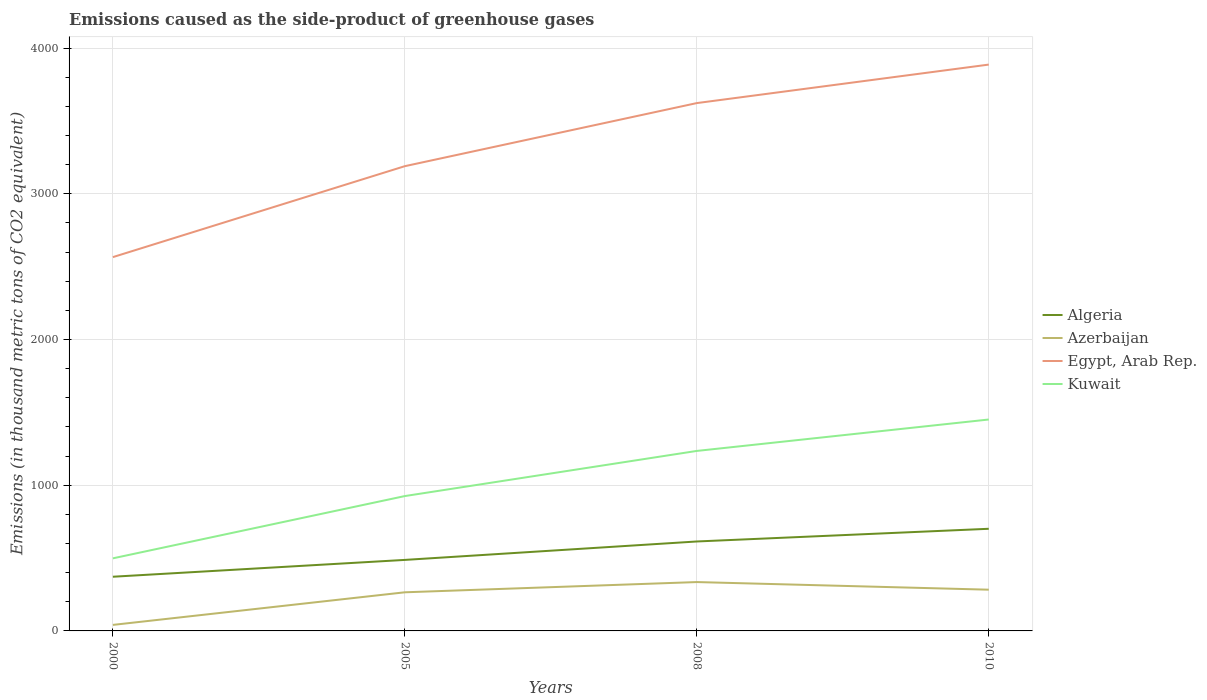How many different coloured lines are there?
Your response must be concise. 4. Across all years, what is the maximum emissions caused as the side-product of greenhouse gases in Egypt, Arab Rep.?
Your answer should be very brief. 2565.6. In which year was the emissions caused as the side-product of greenhouse gases in Azerbaijan maximum?
Your answer should be very brief. 2000. What is the total emissions caused as the side-product of greenhouse gases in Algeria in the graph?
Keep it short and to the point. -242. What is the difference between the highest and the second highest emissions caused as the side-product of greenhouse gases in Azerbaijan?
Offer a very short reply. 294. What is the difference between the highest and the lowest emissions caused as the side-product of greenhouse gases in Algeria?
Make the answer very short. 2. Is the emissions caused as the side-product of greenhouse gases in Algeria strictly greater than the emissions caused as the side-product of greenhouse gases in Azerbaijan over the years?
Make the answer very short. No. How many lines are there?
Make the answer very short. 4. Does the graph contain grids?
Offer a very short reply. Yes. Where does the legend appear in the graph?
Provide a short and direct response. Center right. How are the legend labels stacked?
Offer a terse response. Vertical. What is the title of the graph?
Provide a succinct answer. Emissions caused as the side-product of greenhouse gases. Does "Sierra Leone" appear as one of the legend labels in the graph?
Give a very brief answer. No. What is the label or title of the Y-axis?
Make the answer very short. Emissions (in thousand metric tons of CO2 equivalent). What is the Emissions (in thousand metric tons of CO2 equivalent) of Algeria in 2000?
Make the answer very short. 371.9. What is the Emissions (in thousand metric tons of CO2 equivalent) in Azerbaijan in 2000?
Your answer should be very brief. 41.3. What is the Emissions (in thousand metric tons of CO2 equivalent) of Egypt, Arab Rep. in 2000?
Offer a terse response. 2565.6. What is the Emissions (in thousand metric tons of CO2 equivalent) of Kuwait in 2000?
Provide a short and direct response. 498.2. What is the Emissions (in thousand metric tons of CO2 equivalent) of Algeria in 2005?
Offer a very short reply. 487.4. What is the Emissions (in thousand metric tons of CO2 equivalent) of Azerbaijan in 2005?
Your response must be concise. 265.1. What is the Emissions (in thousand metric tons of CO2 equivalent) in Egypt, Arab Rep. in 2005?
Make the answer very short. 3189.8. What is the Emissions (in thousand metric tons of CO2 equivalent) in Kuwait in 2005?
Make the answer very short. 925.6. What is the Emissions (in thousand metric tons of CO2 equivalent) in Algeria in 2008?
Your response must be concise. 613.9. What is the Emissions (in thousand metric tons of CO2 equivalent) in Azerbaijan in 2008?
Keep it short and to the point. 335.3. What is the Emissions (in thousand metric tons of CO2 equivalent) of Egypt, Arab Rep. in 2008?
Your response must be concise. 3622.8. What is the Emissions (in thousand metric tons of CO2 equivalent) in Kuwait in 2008?
Offer a terse response. 1235.4. What is the Emissions (in thousand metric tons of CO2 equivalent) of Algeria in 2010?
Keep it short and to the point. 701. What is the Emissions (in thousand metric tons of CO2 equivalent) of Azerbaijan in 2010?
Your answer should be very brief. 283. What is the Emissions (in thousand metric tons of CO2 equivalent) in Egypt, Arab Rep. in 2010?
Your response must be concise. 3887. What is the Emissions (in thousand metric tons of CO2 equivalent) of Kuwait in 2010?
Ensure brevity in your answer.  1451. Across all years, what is the maximum Emissions (in thousand metric tons of CO2 equivalent) in Algeria?
Your answer should be compact. 701. Across all years, what is the maximum Emissions (in thousand metric tons of CO2 equivalent) in Azerbaijan?
Ensure brevity in your answer.  335.3. Across all years, what is the maximum Emissions (in thousand metric tons of CO2 equivalent) of Egypt, Arab Rep.?
Offer a terse response. 3887. Across all years, what is the maximum Emissions (in thousand metric tons of CO2 equivalent) in Kuwait?
Offer a very short reply. 1451. Across all years, what is the minimum Emissions (in thousand metric tons of CO2 equivalent) of Algeria?
Keep it short and to the point. 371.9. Across all years, what is the minimum Emissions (in thousand metric tons of CO2 equivalent) of Azerbaijan?
Provide a succinct answer. 41.3. Across all years, what is the minimum Emissions (in thousand metric tons of CO2 equivalent) in Egypt, Arab Rep.?
Keep it short and to the point. 2565.6. Across all years, what is the minimum Emissions (in thousand metric tons of CO2 equivalent) of Kuwait?
Your response must be concise. 498.2. What is the total Emissions (in thousand metric tons of CO2 equivalent) in Algeria in the graph?
Offer a very short reply. 2174.2. What is the total Emissions (in thousand metric tons of CO2 equivalent) of Azerbaijan in the graph?
Offer a very short reply. 924.7. What is the total Emissions (in thousand metric tons of CO2 equivalent) of Egypt, Arab Rep. in the graph?
Provide a short and direct response. 1.33e+04. What is the total Emissions (in thousand metric tons of CO2 equivalent) of Kuwait in the graph?
Your response must be concise. 4110.2. What is the difference between the Emissions (in thousand metric tons of CO2 equivalent) of Algeria in 2000 and that in 2005?
Provide a short and direct response. -115.5. What is the difference between the Emissions (in thousand metric tons of CO2 equivalent) in Azerbaijan in 2000 and that in 2005?
Ensure brevity in your answer.  -223.8. What is the difference between the Emissions (in thousand metric tons of CO2 equivalent) of Egypt, Arab Rep. in 2000 and that in 2005?
Give a very brief answer. -624.2. What is the difference between the Emissions (in thousand metric tons of CO2 equivalent) of Kuwait in 2000 and that in 2005?
Make the answer very short. -427.4. What is the difference between the Emissions (in thousand metric tons of CO2 equivalent) in Algeria in 2000 and that in 2008?
Your answer should be very brief. -242. What is the difference between the Emissions (in thousand metric tons of CO2 equivalent) in Azerbaijan in 2000 and that in 2008?
Your answer should be compact. -294. What is the difference between the Emissions (in thousand metric tons of CO2 equivalent) of Egypt, Arab Rep. in 2000 and that in 2008?
Your answer should be compact. -1057.2. What is the difference between the Emissions (in thousand metric tons of CO2 equivalent) in Kuwait in 2000 and that in 2008?
Your answer should be compact. -737.2. What is the difference between the Emissions (in thousand metric tons of CO2 equivalent) of Algeria in 2000 and that in 2010?
Provide a short and direct response. -329.1. What is the difference between the Emissions (in thousand metric tons of CO2 equivalent) in Azerbaijan in 2000 and that in 2010?
Provide a succinct answer. -241.7. What is the difference between the Emissions (in thousand metric tons of CO2 equivalent) in Egypt, Arab Rep. in 2000 and that in 2010?
Ensure brevity in your answer.  -1321.4. What is the difference between the Emissions (in thousand metric tons of CO2 equivalent) in Kuwait in 2000 and that in 2010?
Your answer should be very brief. -952.8. What is the difference between the Emissions (in thousand metric tons of CO2 equivalent) in Algeria in 2005 and that in 2008?
Your answer should be very brief. -126.5. What is the difference between the Emissions (in thousand metric tons of CO2 equivalent) of Azerbaijan in 2005 and that in 2008?
Your answer should be compact. -70.2. What is the difference between the Emissions (in thousand metric tons of CO2 equivalent) in Egypt, Arab Rep. in 2005 and that in 2008?
Provide a short and direct response. -433. What is the difference between the Emissions (in thousand metric tons of CO2 equivalent) in Kuwait in 2005 and that in 2008?
Offer a very short reply. -309.8. What is the difference between the Emissions (in thousand metric tons of CO2 equivalent) of Algeria in 2005 and that in 2010?
Your answer should be compact. -213.6. What is the difference between the Emissions (in thousand metric tons of CO2 equivalent) in Azerbaijan in 2005 and that in 2010?
Provide a short and direct response. -17.9. What is the difference between the Emissions (in thousand metric tons of CO2 equivalent) in Egypt, Arab Rep. in 2005 and that in 2010?
Ensure brevity in your answer.  -697.2. What is the difference between the Emissions (in thousand metric tons of CO2 equivalent) in Kuwait in 2005 and that in 2010?
Keep it short and to the point. -525.4. What is the difference between the Emissions (in thousand metric tons of CO2 equivalent) in Algeria in 2008 and that in 2010?
Your answer should be very brief. -87.1. What is the difference between the Emissions (in thousand metric tons of CO2 equivalent) in Azerbaijan in 2008 and that in 2010?
Ensure brevity in your answer.  52.3. What is the difference between the Emissions (in thousand metric tons of CO2 equivalent) of Egypt, Arab Rep. in 2008 and that in 2010?
Your answer should be compact. -264.2. What is the difference between the Emissions (in thousand metric tons of CO2 equivalent) of Kuwait in 2008 and that in 2010?
Give a very brief answer. -215.6. What is the difference between the Emissions (in thousand metric tons of CO2 equivalent) in Algeria in 2000 and the Emissions (in thousand metric tons of CO2 equivalent) in Azerbaijan in 2005?
Your answer should be compact. 106.8. What is the difference between the Emissions (in thousand metric tons of CO2 equivalent) in Algeria in 2000 and the Emissions (in thousand metric tons of CO2 equivalent) in Egypt, Arab Rep. in 2005?
Offer a very short reply. -2817.9. What is the difference between the Emissions (in thousand metric tons of CO2 equivalent) of Algeria in 2000 and the Emissions (in thousand metric tons of CO2 equivalent) of Kuwait in 2005?
Your answer should be compact. -553.7. What is the difference between the Emissions (in thousand metric tons of CO2 equivalent) in Azerbaijan in 2000 and the Emissions (in thousand metric tons of CO2 equivalent) in Egypt, Arab Rep. in 2005?
Provide a short and direct response. -3148.5. What is the difference between the Emissions (in thousand metric tons of CO2 equivalent) in Azerbaijan in 2000 and the Emissions (in thousand metric tons of CO2 equivalent) in Kuwait in 2005?
Your answer should be compact. -884.3. What is the difference between the Emissions (in thousand metric tons of CO2 equivalent) of Egypt, Arab Rep. in 2000 and the Emissions (in thousand metric tons of CO2 equivalent) of Kuwait in 2005?
Your response must be concise. 1640. What is the difference between the Emissions (in thousand metric tons of CO2 equivalent) of Algeria in 2000 and the Emissions (in thousand metric tons of CO2 equivalent) of Azerbaijan in 2008?
Your answer should be very brief. 36.6. What is the difference between the Emissions (in thousand metric tons of CO2 equivalent) of Algeria in 2000 and the Emissions (in thousand metric tons of CO2 equivalent) of Egypt, Arab Rep. in 2008?
Your answer should be compact. -3250.9. What is the difference between the Emissions (in thousand metric tons of CO2 equivalent) in Algeria in 2000 and the Emissions (in thousand metric tons of CO2 equivalent) in Kuwait in 2008?
Ensure brevity in your answer.  -863.5. What is the difference between the Emissions (in thousand metric tons of CO2 equivalent) in Azerbaijan in 2000 and the Emissions (in thousand metric tons of CO2 equivalent) in Egypt, Arab Rep. in 2008?
Your response must be concise. -3581.5. What is the difference between the Emissions (in thousand metric tons of CO2 equivalent) in Azerbaijan in 2000 and the Emissions (in thousand metric tons of CO2 equivalent) in Kuwait in 2008?
Keep it short and to the point. -1194.1. What is the difference between the Emissions (in thousand metric tons of CO2 equivalent) in Egypt, Arab Rep. in 2000 and the Emissions (in thousand metric tons of CO2 equivalent) in Kuwait in 2008?
Make the answer very short. 1330.2. What is the difference between the Emissions (in thousand metric tons of CO2 equivalent) in Algeria in 2000 and the Emissions (in thousand metric tons of CO2 equivalent) in Azerbaijan in 2010?
Your answer should be very brief. 88.9. What is the difference between the Emissions (in thousand metric tons of CO2 equivalent) in Algeria in 2000 and the Emissions (in thousand metric tons of CO2 equivalent) in Egypt, Arab Rep. in 2010?
Offer a very short reply. -3515.1. What is the difference between the Emissions (in thousand metric tons of CO2 equivalent) in Algeria in 2000 and the Emissions (in thousand metric tons of CO2 equivalent) in Kuwait in 2010?
Give a very brief answer. -1079.1. What is the difference between the Emissions (in thousand metric tons of CO2 equivalent) in Azerbaijan in 2000 and the Emissions (in thousand metric tons of CO2 equivalent) in Egypt, Arab Rep. in 2010?
Provide a short and direct response. -3845.7. What is the difference between the Emissions (in thousand metric tons of CO2 equivalent) of Azerbaijan in 2000 and the Emissions (in thousand metric tons of CO2 equivalent) of Kuwait in 2010?
Give a very brief answer. -1409.7. What is the difference between the Emissions (in thousand metric tons of CO2 equivalent) in Egypt, Arab Rep. in 2000 and the Emissions (in thousand metric tons of CO2 equivalent) in Kuwait in 2010?
Provide a short and direct response. 1114.6. What is the difference between the Emissions (in thousand metric tons of CO2 equivalent) in Algeria in 2005 and the Emissions (in thousand metric tons of CO2 equivalent) in Azerbaijan in 2008?
Make the answer very short. 152.1. What is the difference between the Emissions (in thousand metric tons of CO2 equivalent) of Algeria in 2005 and the Emissions (in thousand metric tons of CO2 equivalent) of Egypt, Arab Rep. in 2008?
Offer a very short reply. -3135.4. What is the difference between the Emissions (in thousand metric tons of CO2 equivalent) in Algeria in 2005 and the Emissions (in thousand metric tons of CO2 equivalent) in Kuwait in 2008?
Keep it short and to the point. -748. What is the difference between the Emissions (in thousand metric tons of CO2 equivalent) of Azerbaijan in 2005 and the Emissions (in thousand metric tons of CO2 equivalent) of Egypt, Arab Rep. in 2008?
Your answer should be very brief. -3357.7. What is the difference between the Emissions (in thousand metric tons of CO2 equivalent) of Azerbaijan in 2005 and the Emissions (in thousand metric tons of CO2 equivalent) of Kuwait in 2008?
Your response must be concise. -970.3. What is the difference between the Emissions (in thousand metric tons of CO2 equivalent) in Egypt, Arab Rep. in 2005 and the Emissions (in thousand metric tons of CO2 equivalent) in Kuwait in 2008?
Keep it short and to the point. 1954.4. What is the difference between the Emissions (in thousand metric tons of CO2 equivalent) in Algeria in 2005 and the Emissions (in thousand metric tons of CO2 equivalent) in Azerbaijan in 2010?
Provide a short and direct response. 204.4. What is the difference between the Emissions (in thousand metric tons of CO2 equivalent) of Algeria in 2005 and the Emissions (in thousand metric tons of CO2 equivalent) of Egypt, Arab Rep. in 2010?
Ensure brevity in your answer.  -3399.6. What is the difference between the Emissions (in thousand metric tons of CO2 equivalent) of Algeria in 2005 and the Emissions (in thousand metric tons of CO2 equivalent) of Kuwait in 2010?
Provide a short and direct response. -963.6. What is the difference between the Emissions (in thousand metric tons of CO2 equivalent) in Azerbaijan in 2005 and the Emissions (in thousand metric tons of CO2 equivalent) in Egypt, Arab Rep. in 2010?
Give a very brief answer. -3621.9. What is the difference between the Emissions (in thousand metric tons of CO2 equivalent) of Azerbaijan in 2005 and the Emissions (in thousand metric tons of CO2 equivalent) of Kuwait in 2010?
Make the answer very short. -1185.9. What is the difference between the Emissions (in thousand metric tons of CO2 equivalent) in Egypt, Arab Rep. in 2005 and the Emissions (in thousand metric tons of CO2 equivalent) in Kuwait in 2010?
Keep it short and to the point. 1738.8. What is the difference between the Emissions (in thousand metric tons of CO2 equivalent) in Algeria in 2008 and the Emissions (in thousand metric tons of CO2 equivalent) in Azerbaijan in 2010?
Make the answer very short. 330.9. What is the difference between the Emissions (in thousand metric tons of CO2 equivalent) in Algeria in 2008 and the Emissions (in thousand metric tons of CO2 equivalent) in Egypt, Arab Rep. in 2010?
Your answer should be compact. -3273.1. What is the difference between the Emissions (in thousand metric tons of CO2 equivalent) in Algeria in 2008 and the Emissions (in thousand metric tons of CO2 equivalent) in Kuwait in 2010?
Offer a very short reply. -837.1. What is the difference between the Emissions (in thousand metric tons of CO2 equivalent) of Azerbaijan in 2008 and the Emissions (in thousand metric tons of CO2 equivalent) of Egypt, Arab Rep. in 2010?
Offer a very short reply. -3551.7. What is the difference between the Emissions (in thousand metric tons of CO2 equivalent) in Azerbaijan in 2008 and the Emissions (in thousand metric tons of CO2 equivalent) in Kuwait in 2010?
Offer a terse response. -1115.7. What is the difference between the Emissions (in thousand metric tons of CO2 equivalent) of Egypt, Arab Rep. in 2008 and the Emissions (in thousand metric tons of CO2 equivalent) of Kuwait in 2010?
Offer a terse response. 2171.8. What is the average Emissions (in thousand metric tons of CO2 equivalent) of Algeria per year?
Your answer should be compact. 543.55. What is the average Emissions (in thousand metric tons of CO2 equivalent) of Azerbaijan per year?
Keep it short and to the point. 231.18. What is the average Emissions (in thousand metric tons of CO2 equivalent) in Egypt, Arab Rep. per year?
Give a very brief answer. 3316.3. What is the average Emissions (in thousand metric tons of CO2 equivalent) in Kuwait per year?
Your answer should be compact. 1027.55. In the year 2000, what is the difference between the Emissions (in thousand metric tons of CO2 equivalent) of Algeria and Emissions (in thousand metric tons of CO2 equivalent) of Azerbaijan?
Your answer should be compact. 330.6. In the year 2000, what is the difference between the Emissions (in thousand metric tons of CO2 equivalent) of Algeria and Emissions (in thousand metric tons of CO2 equivalent) of Egypt, Arab Rep.?
Offer a very short reply. -2193.7. In the year 2000, what is the difference between the Emissions (in thousand metric tons of CO2 equivalent) of Algeria and Emissions (in thousand metric tons of CO2 equivalent) of Kuwait?
Ensure brevity in your answer.  -126.3. In the year 2000, what is the difference between the Emissions (in thousand metric tons of CO2 equivalent) in Azerbaijan and Emissions (in thousand metric tons of CO2 equivalent) in Egypt, Arab Rep.?
Offer a very short reply. -2524.3. In the year 2000, what is the difference between the Emissions (in thousand metric tons of CO2 equivalent) of Azerbaijan and Emissions (in thousand metric tons of CO2 equivalent) of Kuwait?
Keep it short and to the point. -456.9. In the year 2000, what is the difference between the Emissions (in thousand metric tons of CO2 equivalent) of Egypt, Arab Rep. and Emissions (in thousand metric tons of CO2 equivalent) of Kuwait?
Your response must be concise. 2067.4. In the year 2005, what is the difference between the Emissions (in thousand metric tons of CO2 equivalent) of Algeria and Emissions (in thousand metric tons of CO2 equivalent) of Azerbaijan?
Give a very brief answer. 222.3. In the year 2005, what is the difference between the Emissions (in thousand metric tons of CO2 equivalent) of Algeria and Emissions (in thousand metric tons of CO2 equivalent) of Egypt, Arab Rep.?
Your answer should be compact. -2702.4. In the year 2005, what is the difference between the Emissions (in thousand metric tons of CO2 equivalent) of Algeria and Emissions (in thousand metric tons of CO2 equivalent) of Kuwait?
Provide a short and direct response. -438.2. In the year 2005, what is the difference between the Emissions (in thousand metric tons of CO2 equivalent) in Azerbaijan and Emissions (in thousand metric tons of CO2 equivalent) in Egypt, Arab Rep.?
Your answer should be very brief. -2924.7. In the year 2005, what is the difference between the Emissions (in thousand metric tons of CO2 equivalent) in Azerbaijan and Emissions (in thousand metric tons of CO2 equivalent) in Kuwait?
Your response must be concise. -660.5. In the year 2005, what is the difference between the Emissions (in thousand metric tons of CO2 equivalent) of Egypt, Arab Rep. and Emissions (in thousand metric tons of CO2 equivalent) of Kuwait?
Keep it short and to the point. 2264.2. In the year 2008, what is the difference between the Emissions (in thousand metric tons of CO2 equivalent) in Algeria and Emissions (in thousand metric tons of CO2 equivalent) in Azerbaijan?
Ensure brevity in your answer.  278.6. In the year 2008, what is the difference between the Emissions (in thousand metric tons of CO2 equivalent) of Algeria and Emissions (in thousand metric tons of CO2 equivalent) of Egypt, Arab Rep.?
Keep it short and to the point. -3008.9. In the year 2008, what is the difference between the Emissions (in thousand metric tons of CO2 equivalent) of Algeria and Emissions (in thousand metric tons of CO2 equivalent) of Kuwait?
Offer a terse response. -621.5. In the year 2008, what is the difference between the Emissions (in thousand metric tons of CO2 equivalent) of Azerbaijan and Emissions (in thousand metric tons of CO2 equivalent) of Egypt, Arab Rep.?
Your response must be concise. -3287.5. In the year 2008, what is the difference between the Emissions (in thousand metric tons of CO2 equivalent) in Azerbaijan and Emissions (in thousand metric tons of CO2 equivalent) in Kuwait?
Provide a short and direct response. -900.1. In the year 2008, what is the difference between the Emissions (in thousand metric tons of CO2 equivalent) of Egypt, Arab Rep. and Emissions (in thousand metric tons of CO2 equivalent) of Kuwait?
Make the answer very short. 2387.4. In the year 2010, what is the difference between the Emissions (in thousand metric tons of CO2 equivalent) in Algeria and Emissions (in thousand metric tons of CO2 equivalent) in Azerbaijan?
Give a very brief answer. 418. In the year 2010, what is the difference between the Emissions (in thousand metric tons of CO2 equivalent) of Algeria and Emissions (in thousand metric tons of CO2 equivalent) of Egypt, Arab Rep.?
Keep it short and to the point. -3186. In the year 2010, what is the difference between the Emissions (in thousand metric tons of CO2 equivalent) in Algeria and Emissions (in thousand metric tons of CO2 equivalent) in Kuwait?
Give a very brief answer. -750. In the year 2010, what is the difference between the Emissions (in thousand metric tons of CO2 equivalent) of Azerbaijan and Emissions (in thousand metric tons of CO2 equivalent) of Egypt, Arab Rep.?
Provide a succinct answer. -3604. In the year 2010, what is the difference between the Emissions (in thousand metric tons of CO2 equivalent) in Azerbaijan and Emissions (in thousand metric tons of CO2 equivalent) in Kuwait?
Offer a very short reply. -1168. In the year 2010, what is the difference between the Emissions (in thousand metric tons of CO2 equivalent) in Egypt, Arab Rep. and Emissions (in thousand metric tons of CO2 equivalent) in Kuwait?
Give a very brief answer. 2436. What is the ratio of the Emissions (in thousand metric tons of CO2 equivalent) in Algeria in 2000 to that in 2005?
Ensure brevity in your answer.  0.76. What is the ratio of the Emissions (in thousand metric tons of CO2 equivalent) in Azerbaijan in 2000 to that in 2005?
Give a very brief answer. 0.16. What is the ratio of the Emissions (in thousand metric tons of CO2 equivalent) in Egypt, Arab Rep. in 2000 to that in 2005?
Ensure brevity in your answer.  0.8. What is the ratio of the Emissions (in thousand metric tons of CO2 equivalent) in Kuwait in 2000 to that in 2005?
Your answer should be very brief. 0.54. What is the ratio of the Emissions (in thousand metric tons of CO2 equivalent) in Algeria in 2000 to that in 2008?
Ensure brevity in your answer.  0.61. What is the ratio of the Emissions (in thousand metric tons of CO2 equivalent) in Azerbaijan in 2000 to that in 2008?
Offer a very short reply. 0.12. What is the ratio of the Emissions (in thousand metric tons of CO2 equivalent) in Egypt, Arab Rep. in 2000 to that in 2008?
Your answer should be compact. 0.71. What is the ratio of the Emissions (in thousand metric tons of CO2 equivalent) of Kuwait in 2000 to that in 2008?
Your answer should be very brief. 0.4. What is the ratio of the Emissions (in thousand metric tons of CO2 equivalent) in Algeria in 2000 to that in 2010?
Your answer should be compact. 0.53. What is the ratio of the Emissions (in thousand metric tons of CO2 equivalent) in Azerbaijan in 2000 to that in 2010?
Provide a short and direct response. 0.15. What is the ratio of the Emissions (in thousand metric tons of CO2 equivalent) in Egypt, Arab Rep. in 2000 to that in 2010?
Offer a terse response. 0.66. What is the ratio of the Emissions (in thousand metric tons of CO2 equivalent) in Kuwait in 2000 to that in 2010?
Give a very brief answer. 0.34. What is the ratio of the Emissions (in thousand metric tons of CO2 equivalent) in Algeria in 2005 to that in 2008?
Provide a succinct answer. 0.79. What is the ratio of the Emissions (in thousand metric tons of CO2 equivalent) of Azerbaijan in 2005 to that in 2008?
Offer a terse response. 0.79. What is the ratio of the Emissions (in thousand metric tons of CO2 equivalent) in Egypt, Arab Rep. in 2005 to that in 2008?
Give a very brief answer. 0.88. What is the ratio of the Emissions (in thousand metric tons of CO2 equivalent) of Kuwait in 2005 to that in 2008?
Your response must be concise. 0.75. What is the ratio of the Emissions (in thousand metric tons of CO2 equivalent) of Algeria in 2005 to that in 2010?
Offer a terse response. 0.7. What is the ratio of the Emissions (in thousand metric tons of CO2 equivalent) of Azerbaijan in 2005 to that in 2010?
Give a very brief answer. 0.94. What is the ratio of the Emissions (in thousand metric tons of CO2 equivalent) in Egypt, Arab Rep. in 2005 to that in 2010?
Ensure brevity in your answer.  0.82. What is the ratio of the Emissions (in thousand metric tons of CO2 equivalent) in Kuwait in 2005 to that in 2010?
Ensure brevity in your answer.  0.64. What is the ratio of the Emissions (in thousand metric tons of CO2 equivalent) in Algeria in 2008 to that in 2010?
Provide a short and direct response. 0.88. What is the ratio of the Emissions (in thousand metric tons of CO2 equivalent) in Azerbaijan in 2008 to that in 2010?
Provide a succinct answer. 1.18. What is the ratio of the Emissions (in thousand metric tons of CO2 equivalent) in Egypt, Arab Rep. in 2008 to that in 2010?
Offer a terse response. 0.93. What is the ratio of the Emissions (in thousand metric tons of CO2 equivalent) in Kuwait in 2008 to that in 2010?
Your response must be concise. 0.85. What is the difference between the highest and the second highest Emissions (in thousand metric tons of CO2 equivalent) in Algeria?
Keep it short and to the point. 87.1. What is the difference between the highest and the second highest Emissions (in thousand metric tons of CO2 equivalent) in Azerbaijan?
Your response must be concise. 52.3. What is the difference between the highest and the second highest Emissions (in thousand metric tons of CO2 equivalent) in Egypt, Arab Rep.?
Provide a short and direct response. 264.2. What is the difference between the highest and the second highest Emissions (in thousand metric tons of CO2 equivalent) of Kuwait?
Offer a very short reply. 215.6. What is the difference between the highest and the lowest Emissions (in thousand metric tons of CO2 equivalent) of Algeria?
Offer a very short reply. 329.1. What is the difference between the highest and the lowest Emissions (in thousand metric tons of CO2 equivalent) of Azerbaijan?
Your response must be concise. 294. What is the difference between the highest and the lowest Emissions (in thousand metric tons of CO2 equivalent) in Egypt, Arab Rep.?
Your answer should be very brief. 1321.4. What is the difference between the highest and the lowest Emissions (in thousand metric tons of CO2 equivalent) of Kuwait?
Your answer should be compact. 952.8. 